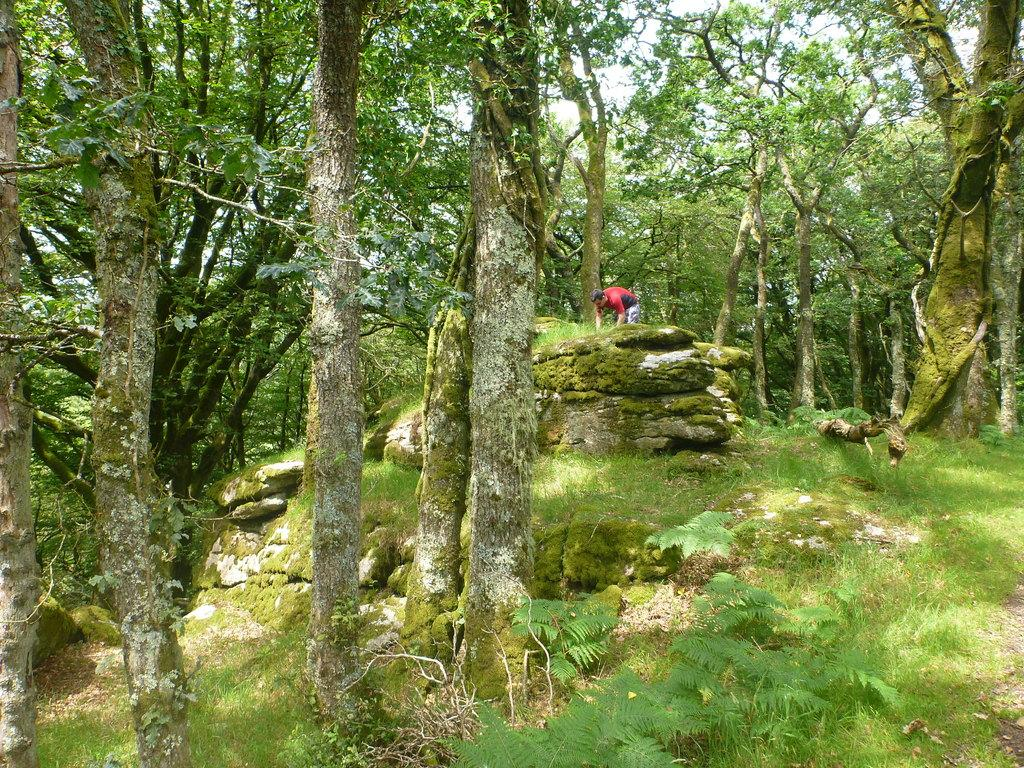What type of vegetation covers the land in the image? The land is covered with grass in the image. What other types of vegetation can be seen in the image? There are plants and trees in the image. Are there any living beings present in the image? Yes, there is a person in the image. What type of pet is the person holding in the image? There is: There is no pet visible in the image; only the person and vegetation are present. 